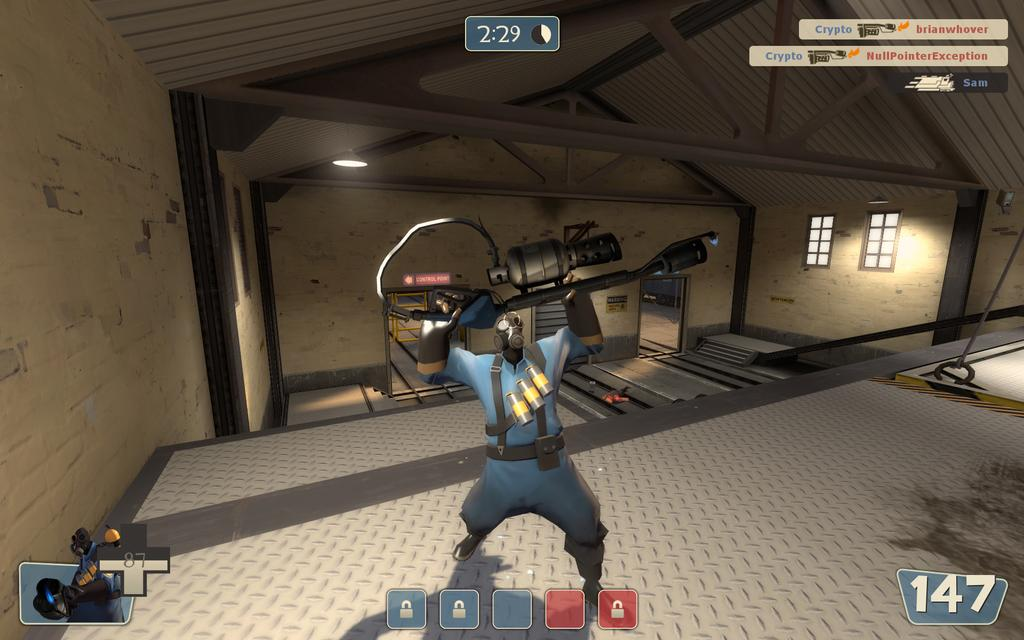What type of image is being described? The image is an animation. Can you describe the main subject in the image? There is a man standing in the center of the image. What is the man holding in the image? The man is holding a gun. What can be seen in the background of the image? There are walls and windows in the background of the image. Where is the light source located in the image? There is a light at the top of the image. Can you tell me how many cribs are visible in the image? There are no cribs present in the image. What type of help is the man providing in the image? The image does not provide information about the man providing help; it only shows him holding a gun. 